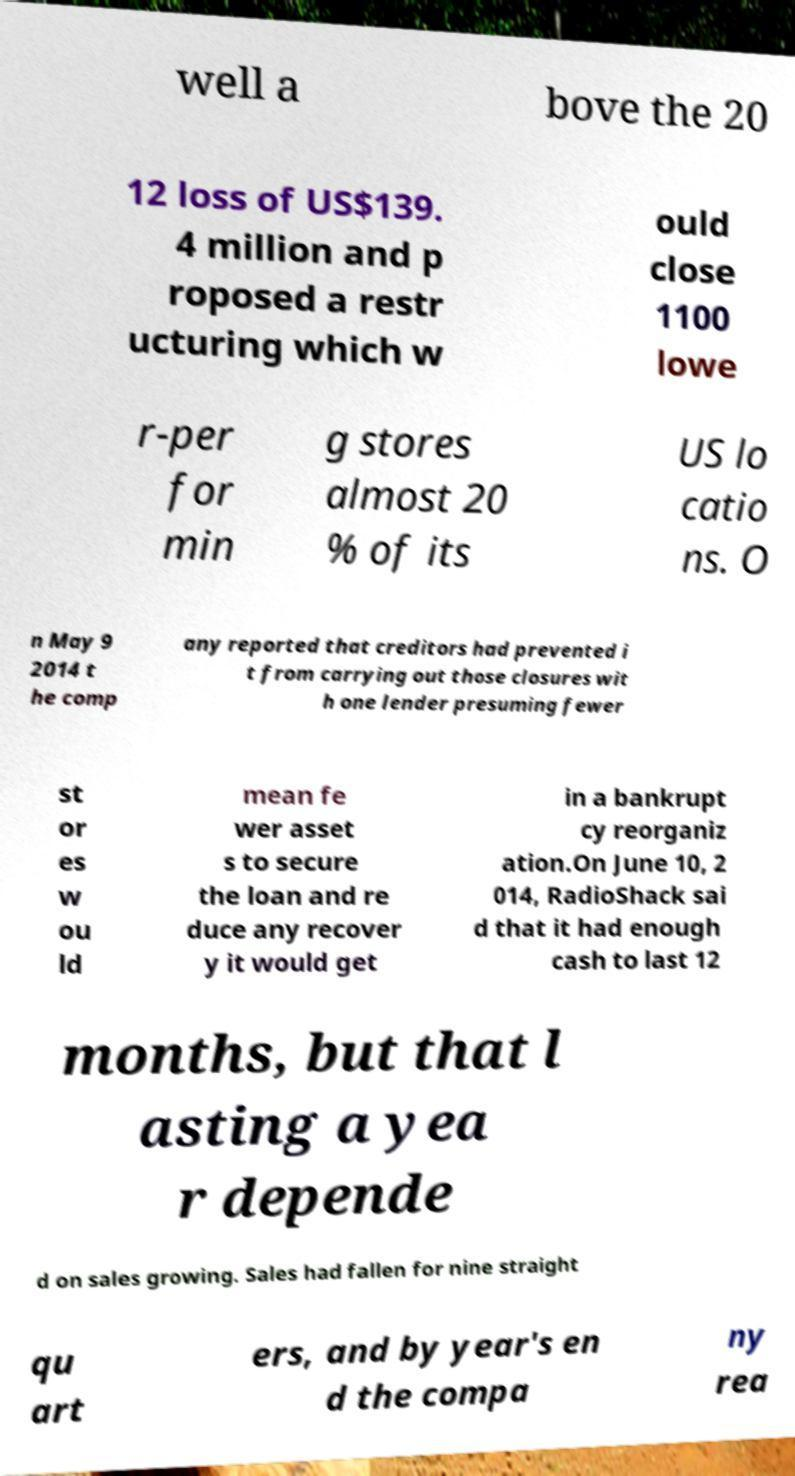Can you read and provide the text displayed in the image?This photo seems to have some interesting text. Can you extract and type it out for me? well a bove the 20 12 loss of US$139. 4 million and p roposed a restr ucturing which w ould close 1100 lowe r-per for min g stores almost 20 % of its US lo catio ns. O n May 9 2014 t he comp any reported that creditors had prevented i t from carrying out those closures wit h one lender presuming fewer st or es w ou ld mean fe wer asset s to secure the loan and re duce any recover y it would get in a bankrupt cy reorganiz ation.On June 10, 2 014, RadioShack sai d that it had enough cash to last 12 months, but that l asting a yea r depende d on sales growing. Sales had fallen for nine straight qu art ers, and by year's en d the compa ny rea 